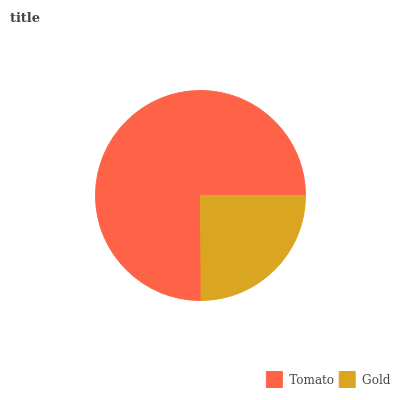Is Gold the minimum?
Answer yes or no. Yes. Is Tomato the maximum?
Answer yes or no. Yes. Is Gold the maximum?
Answer yes or no. No. Is Tomato greater than Gold?
Answer yes or no. Yes. Is Gold less than Tomato?
Answer yes or no. Yes. Is Gold greater than Tomato?
Answer yes or no. No. Is Tomato less than Gold?
Answer yes or no. No. Is Tomato the high median?
Answer yes or no. Yes. Is Gold the low median?
Answer yes or no. Yes. Is Gold the high median?
Answer yes or no. No. Is Tomato the low median?
Answer yes or no. No. 